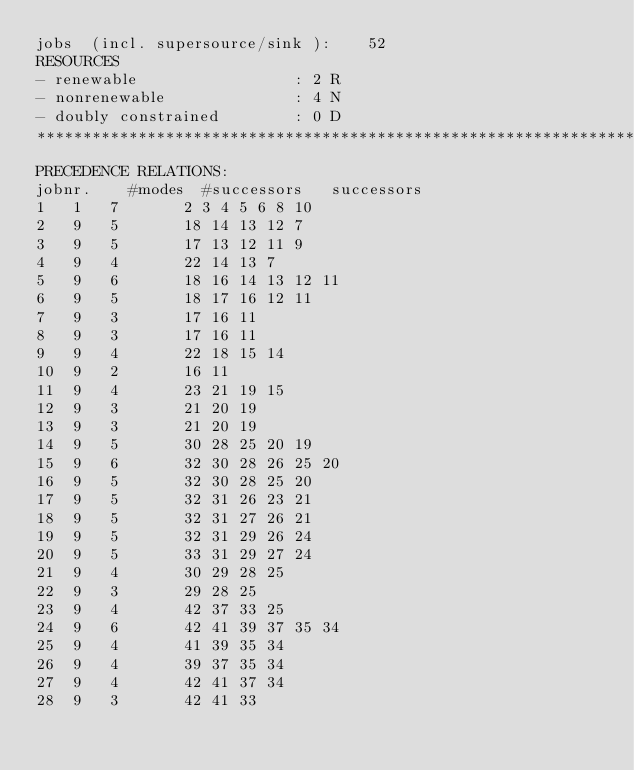<code> <loc_0><loc_0><loc_500><loc_500><_ObjectiveC_>jobs  (incl. supersource/sink ):	52
RESOURCES
- renewable                 : 2 R
- nonrenewable              : 4 N
- doubly constrained        : 0 D
************************************************************************
PRECEDENCE RELATIONS:
jobnr.    #modes  #successors   successors
1	1	7		2 3 4 5 6 8 10 
2	9	5		18 14 13 12 7 
3	9	5		17 13 12 11 9 
4	9	4		22 14 13 7 
5	9	6		18 16 14 13 12 11 
6	9	5		18 17 16 12 11 
7	9	3		17 16 11 
8	9	3		17 16 11 
9	9	4		22 18 15 14 
10	9	2		16 11 
11	9	4		23 21 19 15 
12	9	3		21 20 19 
13	9	3		21 20 19 
14	9	5		30 28 25 20 19 
15	9	6		32 30 28 26 25 20 
16	9	5		32 30 28 25 20 
17	9	5		32 31 26 23 21 
18	9	5		32 31 27 26 21 
19	9	5		32 31 29 26 24 
20	9	5		33 31 29 27 24 
21	9	4		30 29 28 25 
22	9	3		29 28 25 
23	9	4		42 37 33 25 
24	9	6		42 41 39 37 35 34 
25	9	4		41 39 35 34 
26	9	4		39 37 35 34 
27	9	4		42 41 37 34 
28	9	3		42 41 33 </code> 